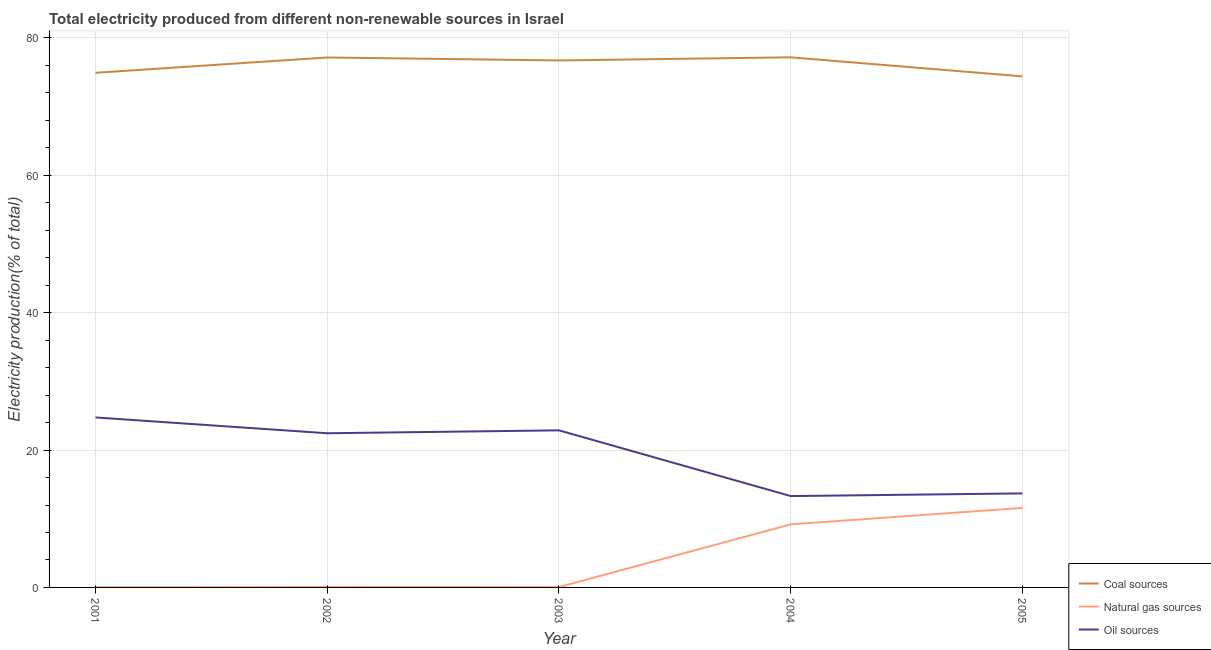How many different coloured lines are there?
Provide a succinct answer. 3. Does the line corresponding to percentage of electricity produced by natural gas intersect with the line corresponding to percentage of electricity produced by coal?
Give a very brief answer. No. Is the number of lines equal to the number of legend labels?
Keep it short and to the point. Yes. What is the percentage of electricity produced by coal in 2002?
Your response must be concise. 77.15. Across all years, what is the maximum percentage of electricity produced by natural gas?
Your answer should be very brief. 11.58. Across all years, what is the minimum percentage of electricity produced by coal?
Ensure brevity in your answer.  74.4. In which year was the percentage of electricity produced by coal maximum?
Your response must be concise. 2004. In which year was the percentage of electricity produced by natural gas minimum?
Make the answer very short. 2001. What is the total percentage of electricity produced by natural gas in the graph?
Offer a very short reply. 20.9. What is the difference between the percentage of electricity produced by natural gas in 2004 and that in 2005?
Your response must be concise. -2.4. What is the difference between the percentage of electricity produced by coal in 2003 and the percentage of electricity produced by natural gas in 2002?
Offer a terse response. 76.66. What is the average percentage of electricity produced by coal per year?
Offer a very short reply. 76.07. In the year 2002, what is the difference between the percentage of electricity produced by natural gas and percentage of electricity produced by coal?
Your answer should be compact. -77.09. In how many years, is the percentage of electricity produced by natural gas greater than 16 %?
Your answer should be very brief. 0. What is the ratio of the percentage of electricity produced by natural gas in 2001 to that in 2003?
Ensure brevity in your answer.  0.56. Is the difference between the percentage of electricity produced by oil sources in 2003 and 2004 greater than the difference between the percentage of electricity produced by coal in 2003 and 2004?
Offer a terse response. Yes. What is the difference between the highest and the second highest percentage of electricity produced by coal?
Keep it short and to the point. 0.02. What is the difference between the highest and the lowest percentage of electricity produced by coal?
Provide a succinct answer. 2.77. In how many years, is the percentage of electricity produced by coal greater than the average percentage of electricity produced by coal taken over all years?
Give a very brief answer. 3. Is it the case that in every year, the sum of the percentage of electricity produced by coal and percentage of electricity produced by natural gas is greater than the percentage of electricity produced by oil sources?
Keep it short and to the point. Yes. What is the difference between two consecutive major ticks on the Y-axis?
Offer a very short reply. 20. Are the values on the major ticks of Y-axis written in scientific E-notation?
Your response must be concise. No. Does the graph contain any zero values?
Keep it short and to the point. No. How many legend labels are there?
Provide a succinct answer. 3. What is the title of the graph?
Your answer should be very brief. Total electricity produced from different non-renewable sources in Israel. What is the label or title of the X-axis?
Provide a short and direct response. Year. What is the Electricity production(% of total) in Coal sources in 2001?
Offer a terse response. 74.92. What is the Electricity production(% of total) of Natural gas sources in 2001?
Offer a very short reply. 0.03. What is the Electricity production(% of total) in Oil sources in 2001?
Offer a very short reply. 24.75. What is the Electricity production(% of total) in Coal sources in 2002?
Provide a short and direct response. 77.15. What is the Electricity production(% of total) of Natural gas sources in 2002?
Make the answer very short. 0.06. What is the Electricity production(% of total) of Oil sources in 2002?
Give a very brief answer. 22.45. What is the Electricity production(% of total) in Coal sources in 2003?
Give a very brief answer. 76.72. What is the Electricity production(% of total) of Natural gas sources in 2003?
Your answer should be very brief. 0.05. What is the Electricity production(% of total) in Oil sources in 2003?
Ensure brevity in your answer.  22.87. What is the Electricity production(% of total) of Coal sources in 2004?
Your answer should be compact. 77.18. What is the Electricity production(% of total) of Natural gas sources in 2004?
Offer a very short reply. 9.18. What is the Electricity production(% of total) of Oil sources in 2004?
Keep it short and to the point. 13.3. What is the Electricity production(% of total) of Coal sources in 2005?
Make the answer very short. 74.4. What is the Electricity production(% of total) of Natural gas sources in 2005?
Offer a very short reply. 11.58. What is the Electricity production(% of total) of Oil sources in 2005?
Your answer should be very brief. 13.69. Across all years, what is the maximum Electricity production(% of total) of Coal sources?
Offer a very short reply. 77.18. Across all years, what is the maximum Electricity production(% of total) of Natural gas sources?
Your answer should be very brief. 11.58. Across all years, what is the maximum Electricity production(% of total) in Oil sources?
Your answer should be very brief. 24.75. Across all years, what is the minimum Electricity production(% of total) of Coal sources?
Keep it short and to the point. 74.4. Across all years, what is the minimum Electricity production(% of total) in Natural gas sources?
Offer a very short reply. 0.03. Across all years, what is the minimum Electricity production(% of total) in Oil sources?
Your answer should be very brief. 13.3. What is the total Electricity production(% of total) in Coal sources in the graph?
Ensure brevity in your answer.  380.37. What is the total Electricity production(% of total) of Natural gas sources in the graph?
Provide a succinct answer. 20.9. What is the total Electricity production(% of total) of Oil sources in the graph?
Your response must be concise. 97.05. What is the difference between the Electricity production(% of total) of Coal sources in 2001 and that in 2002?
Provide a succinct answer. -2.23. What is the difference between the Electricity production(% of total) in Natural gas sources in 2001 and that in 2002?
Offer a very short reply. -0.03. What is the difference between the Electricity production(% of total) in Oil sources in 2001 and that in 2002?
Offer a terse response. 2.3. What is the difference between the Electricity production(% of total) in Coal sources in 2001 and that in 2003?
Offer a very short reply. -1.8. What is the difference between the Electricity production(% of total) in Natural gas sources in 2001 and that in 2003?
Ensure brevity in your answer.  -0.02. What is the difference between the Electricity production(% of total) in Oil sources in 2001 and that in 2003?
Give a very brief answer. 1.88. What is the difference between the Electricity production(% of total) in Coal sources in 2001 and that in 2004?
Offer a terse response. -2.25. What is the difference between the Electricity production(% of total) in Natural gas sources in 2001 and that in 2004?
Offer a terse response. -9.15. What is the difference between the Electricity production(% of total) of Oil sources in 2001 and that in 2004?
Provide a succinct answer. 11.45. What is the difference between the Electricity production(% of total) in Coal sources in 2001 and that in 2005?
Your answer should be compact. 0.52. What is the difference between the Electricity production(% of total) in Natural gas sources in 2001 and that in 2005?
Provide a succinct answer. -11.55. What is the difference between the Electricity production(% of total) of Oil sources in 2001 and that in 2005?
Your response must be concise. 11.05. What is the difference between the Electricity production(% of total) in Coal sources in 2002 and that in 2003?
Provide a short and direct response. 0.43. What is the difference between the Electricity production(% of total) of Natural gas sources in 2002 and that in 2003?
Provide a succinct answer. 0.01. What is the difference between the Electricity production(% of total) in Oil sources in 2002 and that in 2003?
Give a very brief answer. -0.42. What is the difference between the Electricity production(% of total) of Coal sources in 2002 and that in 2004?
Provide a short and direct response. -0.02. What is the difference between the Electricity production(% of total) in Natural gas sources in 2002 and that in 2004?
Offer a very short reply. -9.12. What is the difference between the Electricity production(% of total) of Oil sources in 2002 and that in 2004?
Your answer should be compact. 9.15. What is the difference between the Electricity production(% of total) in Coal sources in 2002 and that in 2005?
Give a very brief answer. 2.75. What is the difference between the Electricity production(% of total) in Natural gas sources in 2002 and that in 2005?
Provide a short and direct response. -11.52. What is the difference between the Electricity production(% of total) of Oil sources in 2002 and that in 2005?
Ensure brevity in your answer.  8.76. What is the difference between the Electricity production(% of total) in Coal sources in 2003 and that in 2004?
Provide a short and direct response. -0.46. What is the difference between the Electricity production(% of total) of Natural gas sources in 2003 and that in 2004?
Offer a very short reply. -9.13. What is the difference between the Electricity production(% of total) of Oil sources in 2003 and that in 2004?
Your answer should be compact. 9.57. What is the difference between the Electricity production(% of total) in Coal sources in 2003 and that in 2005?
Keep it short and to the point. 2.32. What is the difference between the Electricity production(% of total) of Natural gas sources in 2003 and that in 2005?
Your answer should be very brief. -11.52. What is the difference between the Electricity production(% of total) of Oil sources in 2003 and that in 2005?
Your response must be concise. 9.18. What is the difference between the Electricity production(% of total) of Coal sources in 2004 and that in 2005?
Your answer should be very brief. 2.77. What is the difference between the Electricity production(% of total) of Natural gas sources in 2004 and that in 2005?
Offer a very short reply. -2.4. What is the difference between the Electricity production(% of total) in Oil sources in 2004 and that in 2005?
Your answer should be very brief. -0.39. What is the difference between the Electricity production(% of total) in Coal sources in 2001 and the Electricity production(% of total) in Natural gas sources in 2002?
Your response must be concise. 74.86. What is the difference between the Electricity production(% of total) in Coal sources in 2001 and the Electricity production(% of total) in Oil sources in 2002?
Your response must be concise. 52.48. What is the difference between the Electricity production(% of total) of Natural gas sources in 2001 and the Electricity production(% of total) of Oil sources in 2002?
Your answer should be very brief. -22.42. What is the difference between the Electricity production(% of total) in Coal sources in 2001 and the Electricity production(% of total) in Natural gas sources in 2003?
Your response must be concise. 74.87. What is the difference between the Electricity production(% of total) of Coal sources in 2001 and the Electricity production(% of total) of Oil sources in 2003?
Offer a terse response. 52.05. What is the difference between the Electricity production(% of total) in Natural gas sources in 2001 and the Electricity production(% of total) in Oil sources in 2003?
Give a very brief answer. -22.84. What is the difference between the Electricity production(% of total) in Coal sources in 2001 and the Electricity production(% of total) in Natural gas sources in 2004?
Keep it short and to the point. 65.74. What is the difference between the Electricity production(% of total) in Coal sources in 2001 and the Electricity production(% of total) in Oil sources in 2004?
Offer a terse response. 61.62. What is the difference between the Electricity production(% of total) of Natural gas sources in 2001 and the Electricity production(% of total) of Oil sources in 2004?
Offer a very short reply. -13.27. What is the difference between the Electricity production(% of total) in Coal sources in 2001 and the Electricity production(% of total) in Natural gas sources in 2005?
Make the answer very short. 63.34. What is the difference between the Electricity production(% of total) in Coal sources in 2001 and the Electricity production(% of total) in Oil sources in 2005?
Provide a succinct answer. 61.23. What is the difference between the Electricity production(% of total) in Natural gas sources in 2001 and the Electricity production(% of total) in Oil sources in 2005?
Make the answer very short. -13.66. What is the difference between the Electricity production(% of total) in Coal sources in 2002 and the Electricity production(% of total) in Natural gas sources in 2003?
Your answer should be compact. 77.1. What is the difference between the Electricity production(% of total) of Coal sources in 2002 and the Electricity production(% of total) of Oil sources in 2003?
Give a very brief answer. 54.28. What is the difference between the Electricity production(% of total) of Natural gas sources in 2002 and the Electricity production(% of total) of Oil sources in 2003?
Keep it short and to the point. -22.81. What is the difference between the Electricity production(% of total) of Coal sources in 2002 and the Electricity production(% of total) of Natural gas sources in 2004?
Provide a short and direct response. 67.97. What is the difference between the Electricity production(% of total) of Coal sources in 2002 and the Electricity production(% of total) of Oil sources in 2004?
Your answer should be very brief. 63.85. What is the difference between the Electricity production(% of total) in Natural gas sources in 2002 and the Electricity production(% of total) in Oil sources in 2004?
Your response must be concise. -13.24. What is the difference between the Electricity production(% of total) in Coal sources in 2002 and the Electricity production(% of total) in Natural gas sources in 2005?
Offer a very short reply. 65.58. What is the difference between the Electricity production(% of total) of Coal sources in 2002 and the Electricity production(% of total) of Oil sources in 2005?
Make the answer very short. 63.46. What is the difference between the Electricity production(% of total) of Natural gas sources in 2002 and the Electricity production(% of total) of Oil sources in 2005?
Your answer should be very brief. -13.63. What is the difference between the Electricity production(% of total) in Coal sources in 2003 and the Electricity production(% of total) in Natural gas sources in 2004?
Provide a succinct answer. 67.54. What is the difference between the Electricity production(% of total) in Coal sources in 2003 and the Electricity production(% of total) in Oil sources in 2004?
Provide a succinct answer. 63.42. What is the difference between the Electricity production(% of total) in Natural gas sources in 2003 and the Electricity production(% of total) in Oil sources in 2004?
Provide a succinct answer. -13.25. What is the difference between the Electricity production(% of total) of Coal sources in 2003 and the Electricity production(% of total) of Natural gas sources in 2005?
Keep it short and to the point. 65.14. What is the difference between the Electricity production(% of total) of Coal sources in 2003 and the Electricity production(% of total) of Oil sources in 2005?
Offer a terse response. 63.03. What is the difference between the Electricity production(% of total) of Natural gas sources in 2003 and the Electricity production(% of total) of Oil sources in 2005?
Your answer should be compact. -13.64. What is the difference between the Electricity production(% of total) of Coal sources in 2004 and the Electricity production(% of total) of Natural gas sources in 2005?
Provide a succinct answer. 65.6. What is the difference between the Electricity production(% of total) of Coal sources in 2004 and the Electricity production(% of total) of Oil sources in 2005?
Offer a terse response. 63.49. What is the difference between the Electricity production(% of total) in Natural gas sources in 2004 and the Electricity production(% of total) in Oil sources in 2005?
Provide a short and direct response. -4.51. What is the average Electricity production(% of total) in Coal sources per year?
Your answer should be very brief. 76.07. What is the average Electricity production(% of total) in Natural gas sources per year?
Provide a succinct answer. 4.18. What is the average Electricity production(% of total) of Oil sources per year?
Ensure brevity in your answer.  19.41. In the year 2001, what is the difference between the Electricity production(% of total) in Coal sources and Electricity production(% of total) in Natural gas sources?
Make the answer very short. 74.89. In the year 2001, what is the difference between the Electricity production(% of total) in Coal sources and Electricity production(% of total) in Oil sources?
Give a very brief answer. 50.18. In the year 2001, what is the difference between the Electricity production(% of total) of Natural gas sources and Electricity production(% of total) of Oil sources?
Your answer should be very brief. -24.72. In the year 2002, what is the difference between the Electricity production(% of total) in Coal sources and Electricity production(% of total) in Natural gas sources?
Your response must be concise. 77.09. In the year 2002, what is the difference between the Electricity production(% of total) in Coal sources and Electricity production(% of total) in Oil sources?
Keep it short and to the point. 54.71. In the year 2002, what is the difference between the Electricity production(% of total) of Natural gas sources and Electricity production(% of total) of Oil sources?
Make the answer very short. -22.38. In the year 2003, what is the difference between the Electricity production(% of total) in Coal sources and Electricity production(% of total) in Natural gas sources?
Provide a succinct answer. 76.67. In the year 2003, what is the difference between the Electricity production(% of total) of Coal sources and Electricity production(% of total) of Oil sources?
Your response must be concise. 53.85. In the year 2003, what is the difference between the Electricity production(% of total) in Natural gas sources and Electricity production(% of total) in Oil sources?
Keep it short and to the point. -22.82. In the year 2004, what is the difference between the Electricity production(% of total) of Coal sources and Electricity production(% of total) of Natural gas sources?
Make the answer very short. 67.99. In the year 2004, what is the difference between the Electricity production(% of total) in Coal sources and Electricity production(% of total) in Oil sources?
Provide a succinct answer. 63.88. In the year 2004, what is the difference between the Electricity production(% of total) in Natural gas sources and Electricity production(% of total) in Oil sources?
Provide a short and direct response. -4.12. In the year 2005, what is the difference between the Electricity production(% of total) of Coal sources and Electricity production(% of total) of Natural gas sources?
Your answer should be compact. 62.82. In the year 2005, what is the difference between the Electricity production(% of total) of Coal sources and Electricity production(% of total) of Oil sources?
Your response must be concise. 60.71. In the year 2005, what is the difference between the Electricity production(% of total) of Natural gas sources and Electricity production(% of total) of Oil sources?
Offer a terse response. -2.11. What is the ratio of the Electricity production(% of total) in Coal sources in 2001 to that in 2002?
Ensure brevity in your answer.  0.97. What is the ratio of the Electricity production(% of total) of Natural gas sources in 2001 to that in 2002?
Give a very brief answer. 0.48. What is the ratio of the Electricity production(% of total) in Oil sources in 2001 to that in 2002?
Give a very brief answer. 1.1. What is the ratio of the Electricity production(% of total) in Coal sources in 2001 to that in 2003?
Make the answer very short. 0.98. What is the ratio of the Electricity production(% of total) of Natural gas sources in 2001 to that in 2003?
Provide a short and direct response. 0.56. What is the ratio of the Electricity production(% of total) of Oil sources in 2001 to that in 2003?
Your answer should be very brief. 1.08. What is the ratio of the Electricity production(% of total) in Coal sources in 2001 to that in 2004?
Keep it short and to the point. 0.97. What is the ratio of the Electricity production(% of total) in Natural gas sources in 2001 to that in 2004?
Your answer should be compact. 0. What is the ratio of the Electricity production(% of total) of Oil sources in 2001 to that in 2004?
Give a very brief answer. 1.86. What is the ratio of the Electricity production(% of total) of Coal sources in 2001 to that in 2005?
Your answer should be very brief. 1.01. What is the ratio of the Electricity production(% of total) in Natural gas sources in 2001 to that in 2005?
Provide a short and direct response. 0. What is the ratio of the Electricity production(% of total) in Oil sources in 2001 to that in 2005?
Make the answer very short. 1.81. What is the ratio of the Electricity production(% of total) of Natural gas sources in 2002 to that in 2003?
Make the answer very short. 1.16. What is the ratio of the Electricity production(% of total) in Oil sources in 2002 to that in 2003?
Ensure brevity in your answer.  0.98. What is the ratio of the Electricity production(% of total) of Coal sources in 2002 to that in 2004?
Offer a very short reply. 1. What is the ratio of the Electricity production(% of total) in Natural gas sources in 2002 to that in 2004?
Give a very brief answer. 0.01. What is the ratio of the Electricity production(% of total) in Oil sources in 2002 to that in 2004?
Make the answer very short. 1.69. What is the ratio of the Electricity production(% of total) of Natural gas sources in 2002 to that in 2005?
Your response must be concise. 0.01. What is the ratio of the Electricity production(% of total) in Oil sources in 2002 to that in 2005?
Provide a succinct answer. 1.64. What is the ratio of the Electricity production(% of total) of Coal sources in 2003 to that in 2004?
Your answer should be very brief. 0.99. What is the ratio of the Electricity production(% of total) of Natural gas sources in 2003 to that in 2004?
Offer a terse response. 0.01. What is the ratio of the Electricity production(% of total) of Oil sources in 2003 to that in 2004?
Make the answer very short. 1.72. What is the ratio of the Electricity production(% of total) in Coal sources in 2003 to that in 2005?
Keep it short and to the point. 1.03. What is the ratio of the Electricity production(% of total) in Natural gas sources in 2003 to that in 2005?
Your answer should be compact. 0. What is the ratio of the Electricity production(% of total) in Oil sources in 2003 to that in 2005?
Your answer should be compact. 1.67. What is the ratio of the Electricity production(% of total) of Coal sources in 2004 to that in 2005?
Offer a terse response. 1.04. What is the ratio of the Electricity production(% of total) in Natural gas sources in 2004 to that in 2005?
Make the answer very short. 0.79. What is the ratio of the Electricity production(% of total) of Oil sources in 2004 to that in 2005?
Provide a succinct answer. 0.97. What is the difference between the highest and the second highest Electricity production(% of total) in Coal sources?
Keep it short and to the point. 0.02. What is the difference between the highest and the second highest Electricity production(% of total) of Natural gas sources?
Ensure brevity in your answer.  2.4. What is the difference between the highest and the second highest Electricity production(% of total) of Oil sources?
Make the answer very short. 1.88. What is the difference between the highest and the lowest Electricity production(% of total) of Coal sources?
Your answer should be compact. 2.77. What is the difference between the highest and the lowest Electricity production(% of total) of Natural gas sources?
Provide a short and direct response. 11.55. What is the difference between the highest and the lowest Electricity production(% of total) of Oil sources?
Offer a terse response. 11.45. 